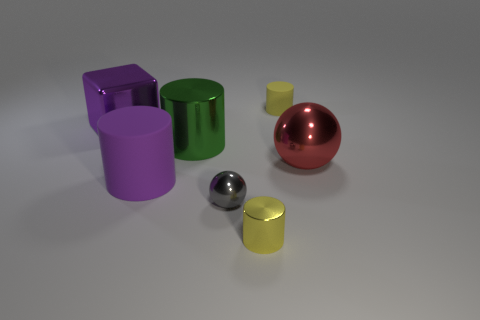What can you infer about the lighting source in the scene? The lighting seems to come from above, given the way shadows are cast below and to the sides of the objects. The softness of the shadows suggests the lighting is diffused rather than direct. 